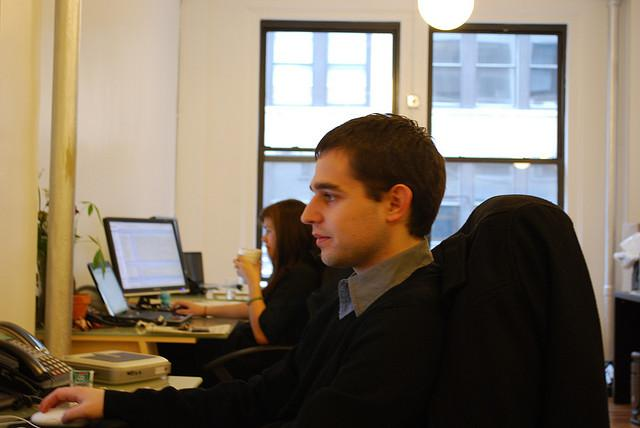What is he doing?

Choices:
A) watching tv
B) making dinner
C) using computer
D) showing off using computer 